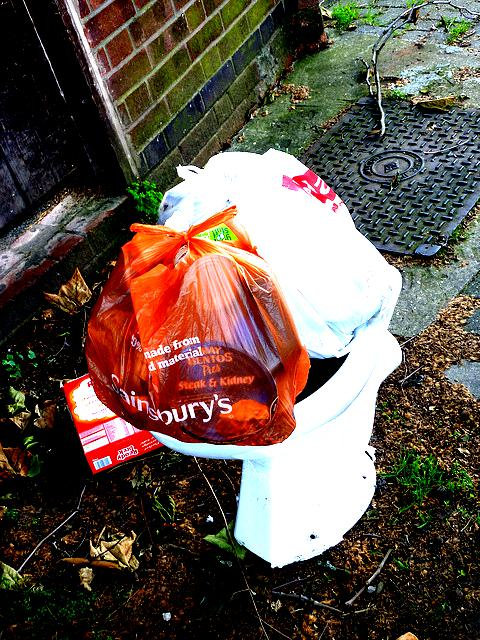Can you describe what's in the picture? The image depicts a scene of urban littering. There's a white plastic bucket overflowing with rubbish bags, notably one that seems to be from a store named 'Sainsbury's'. Additionally, there's a discarded beverage carton on the ground near the bucket, contributing to the untidy state of the area. What could be the implications of such littering? Littering like this can have numerous negative implications. Environmentally, it can lead to pollution and harm local wildlife. It can also have social consequences, such as attracting pests, contributing to unsanitary conditions, and decreasing the aesthetic appeal of the area, possibly reducing property values. Furthermore, it can reflect a lack of community engagement and civic responsibility. 